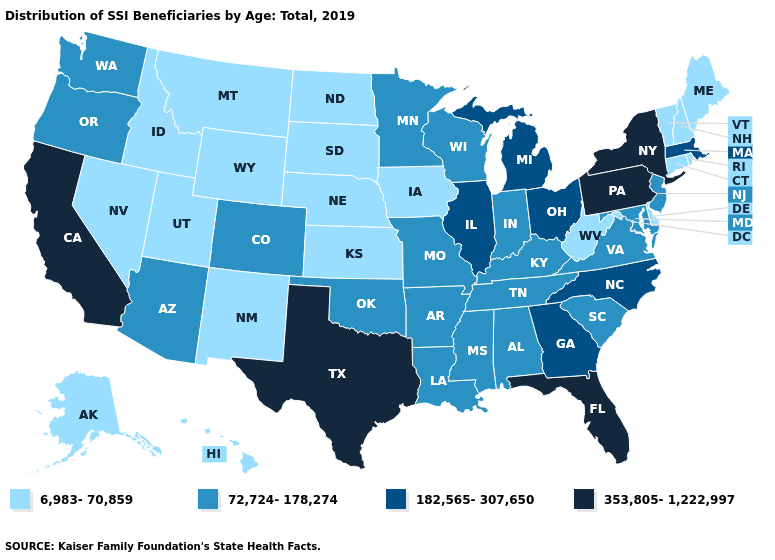Name the states that have a value in the range 182,565-307,650?
Answer briefly. Georgia, Illinois, Massachusetts, Michigan, North Carolina, Ohio. Name the states that have a value in the range 182,565-307,650?
Answer briefly. Georgia, Illinois, Massachusetts, Michigan, North Carolina, Ohio. Which states have the highest value in the USA?
Keep it brief. California, Florida, New York, Pennsylvania, Texas. Is the legend a continuous bar?
Keep it brief. No. Name the states that have a value in the range 353,805-1,222,997?
Short answer required. California, Florida, New York, Pennsylvania, Texas. Does Kansas have the lowest value in the MidWest?
Give a very brief answer. Yes. What is the lowest value in the West?
Give a very brief answer. 6,983-70,859. Name the states that have a value in the range 353,805-1,222,997?
Write a very short answer. California, Florida, New York, Pennsylvania, Texas. Is the legend a continuous bar?
Concise answer only. No. Which states hav the highest value in the West?
Keep it brief. California. What is the value of Georgia?
Keep it brief. 182,565-307,650. What is the lowest value in the South?
Be succinct. 6,983-70,859. Name the states that have a value in the range 6,983-70,859?
Be succinct. Alaska, Connecticut, Delaware, Hawaii, Idaho, Iowa, Kansas, Maine, Montana, Nebraska, Nevada, New Hampshire, New Mexico, North Dakota, Rhode Island, South Dakota, Utah, Vermont, West Virginia, Wyoming. What is the value of Iowa?
Answer briefly. 6,983-70,859. What is the value of Hawaii?
Give a very brief answer. 6,983-70,859. 